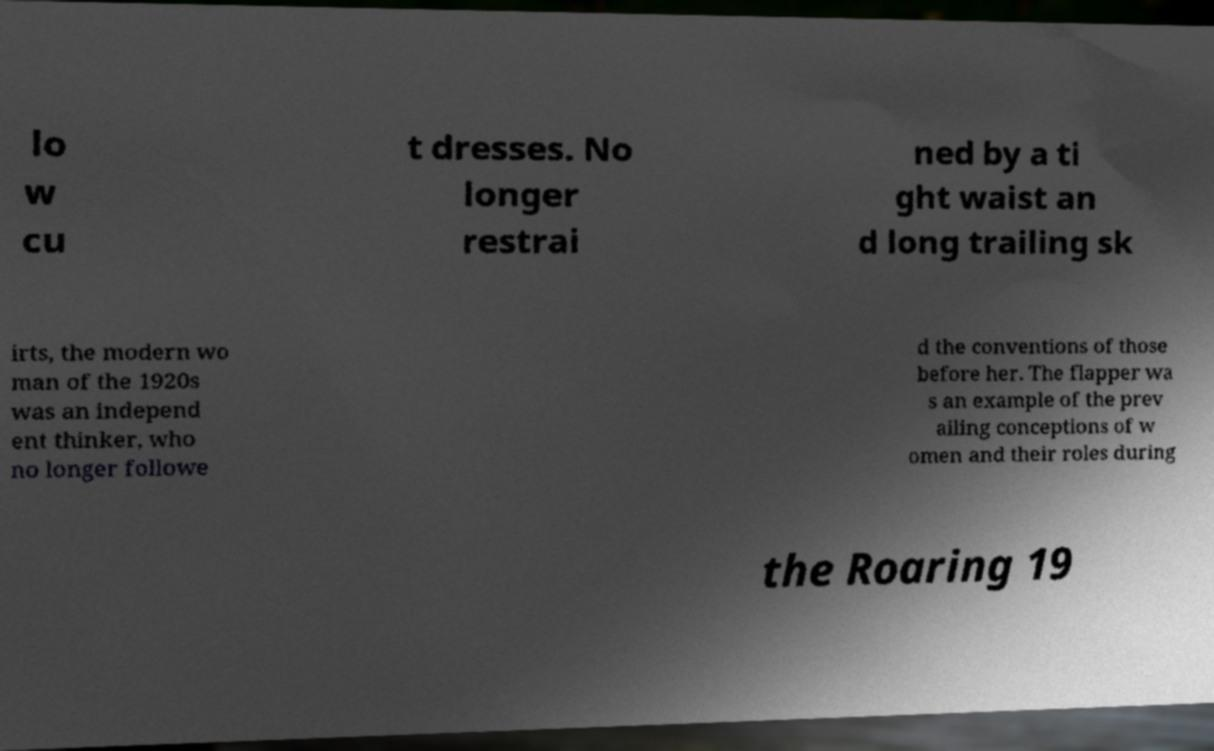I need the written content from this picture converted into text. Can you do that? lo w cu t dresses. No longer restrai ned by a ti ght waist an d long trailing sk irts, the modern wo man of the 1920s was an independ ent thinker, who no longer followe d the conventions of those before her. The flapper wa s an example of the prev ailing conceptions of w omen and their roles during the Roaring 19 